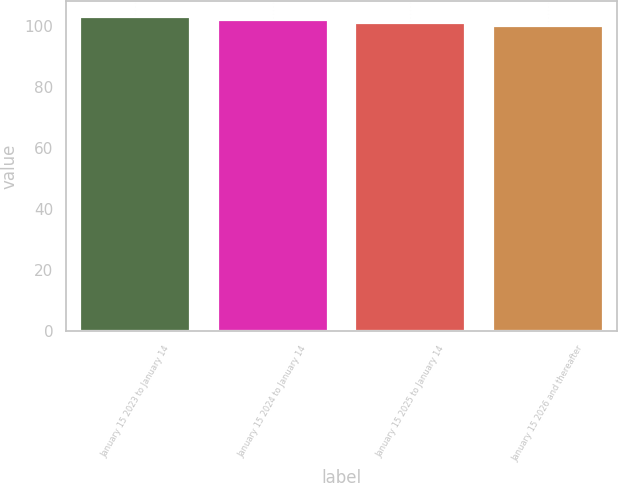<chart> <loc_0><loc_0><loc_500><loc_500><bar_chart><fcel>January 15 2023 to January 14<fcel>January 15 2024 to January 14<fcel>January 15 2025 to January 14<fcel>January 15 2026 and thereafter<nl><fcel>102.88<fcel>101.92<fcel>100.96<fcel>100<nl></chart> 